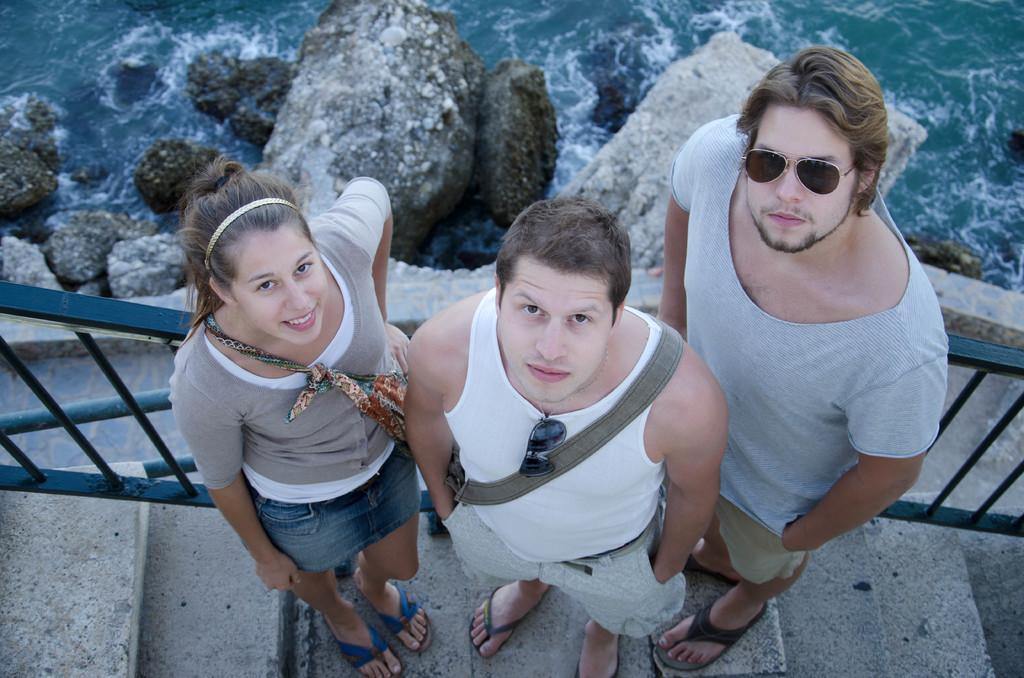Please provide a concise description of this image. In this image we can see person standing on steps. One person is wearing goggles. Another person is wearing a bag and keeping a goggles on the vest. Another person is wearing a bag. In the back there are rocks and water. 